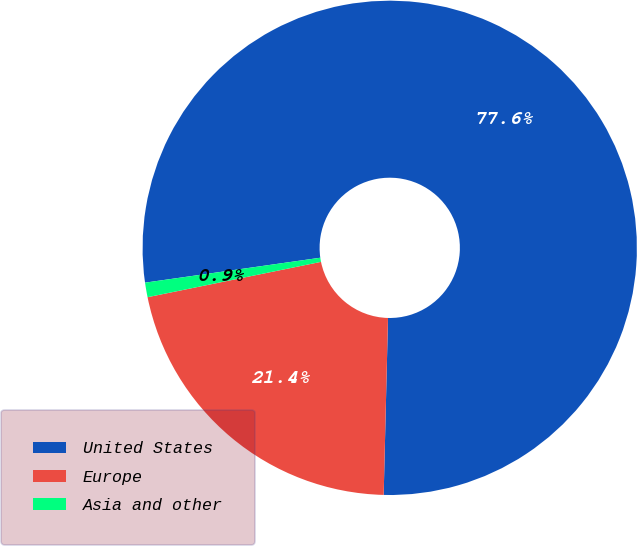Convert chart to OTSL. <chart><loc_0><loc_0><loc_500><loc_500><pie_chart><fcel>United States<fcel>Europe<fcel>Asia and other<nl><fcel>77.64%<fcel>21.41%<fcel>0.95%<nl></chart> 